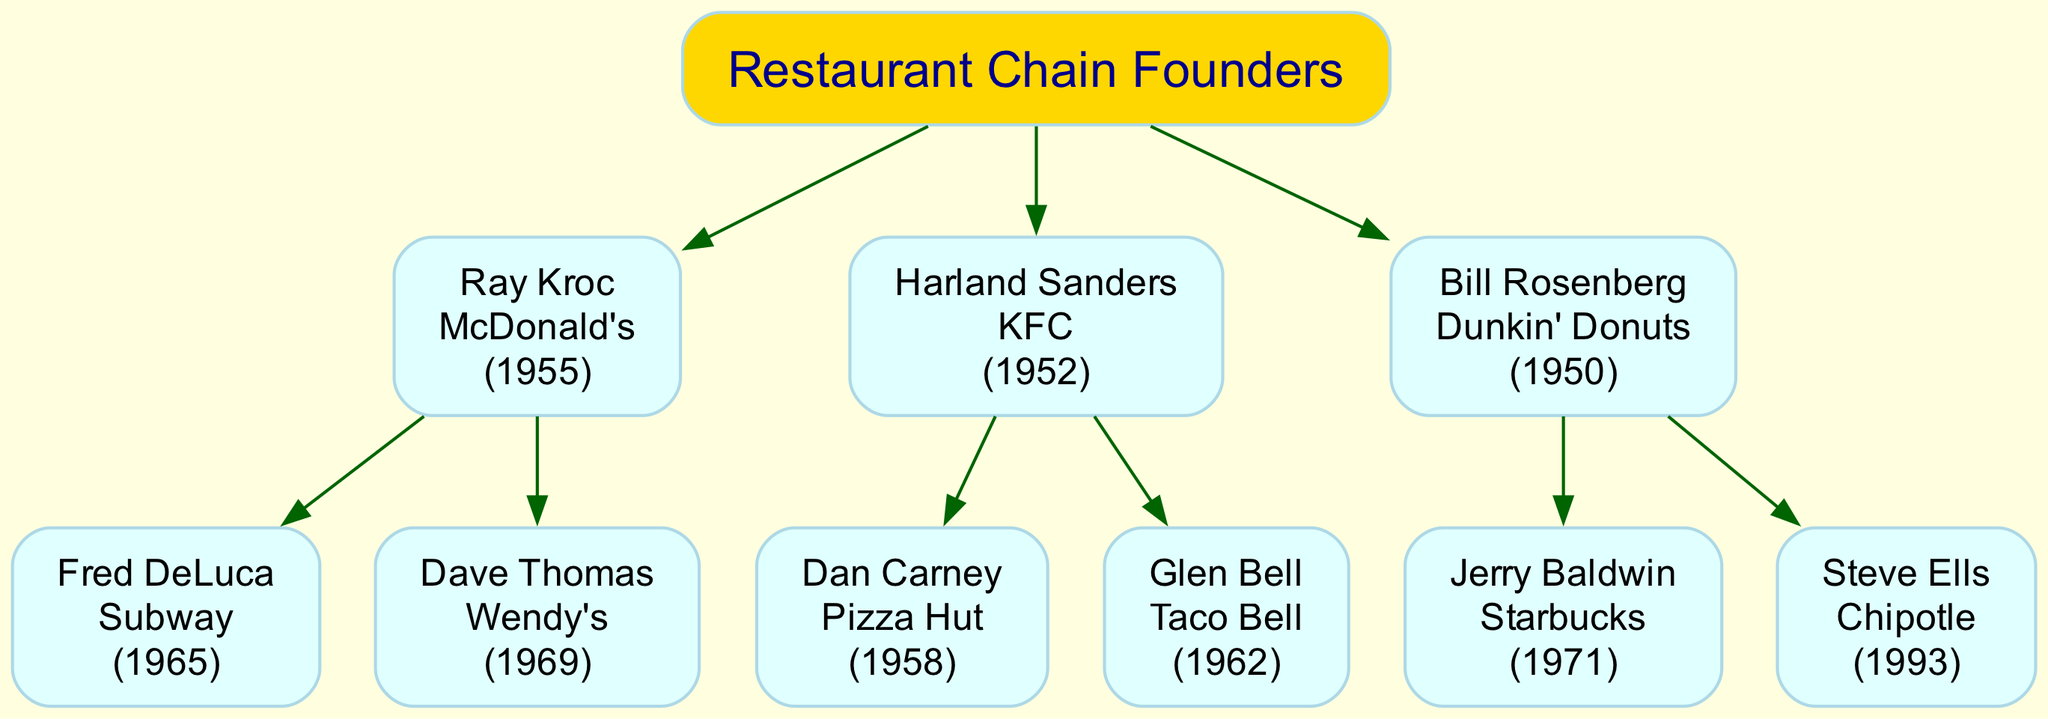What is the founding year of McDonald's? The diagram lists Ray Kroc as the founder of McDonald's, and it specifies the founding year as 1955.
Answer: 1955 Who founded KFC? According to the diagram, Harland Sanders is identified as the founder of KFC.
Answer: Harland Sanders How many children does Bill Rosenberg have in the diagram? The diagram shows Bill Rosenberg as having two children listed under him, which are Jerry Baldwin and Steve Ells.
Answer: 2 Which restaurant chain was founded by Dave Thomas? The diagram indicates that Dave Thomas is the founder of Wendy's, as stated in his corresponding node within the hierarchy.
Answer: Wendy's Which restaurant chain was founded first, Taco Bell or Pizza Hut? The diagram shows that Taco Bell was founded by Glen Bell in 1962 and Pizza Hut was founded by Dan Carney in 1958, indicating that Pizza Hut was founded first.
Answer: Pizza Hut Who is the youngest founder in the diagram? By examining the founding years listed for all founders, Steve Ells founded Chipotle in 1993, making him the youngest compared to others who founded earlier.
Answer: Steve Ells What restaurant chain has a founder born in 1950? The diagram reveals that Dunkin' Donuts was founded by Bill Rosenberg in 1950.
Answer: Dunkin' Donuts Which founder's company was established just before McDonald's? Looking at the years, KFC was founded by Harland Sanders in 1952, which is just before McDonald's, founded in 1955 by Ray Kroc.
Answer: KFC What color represents the root node in the diagram? The root node, labeled "Restaurant Chain Founders," is filled with the color gold as indicated by its specified attributes in the diagram setup.
Answer: Gold 